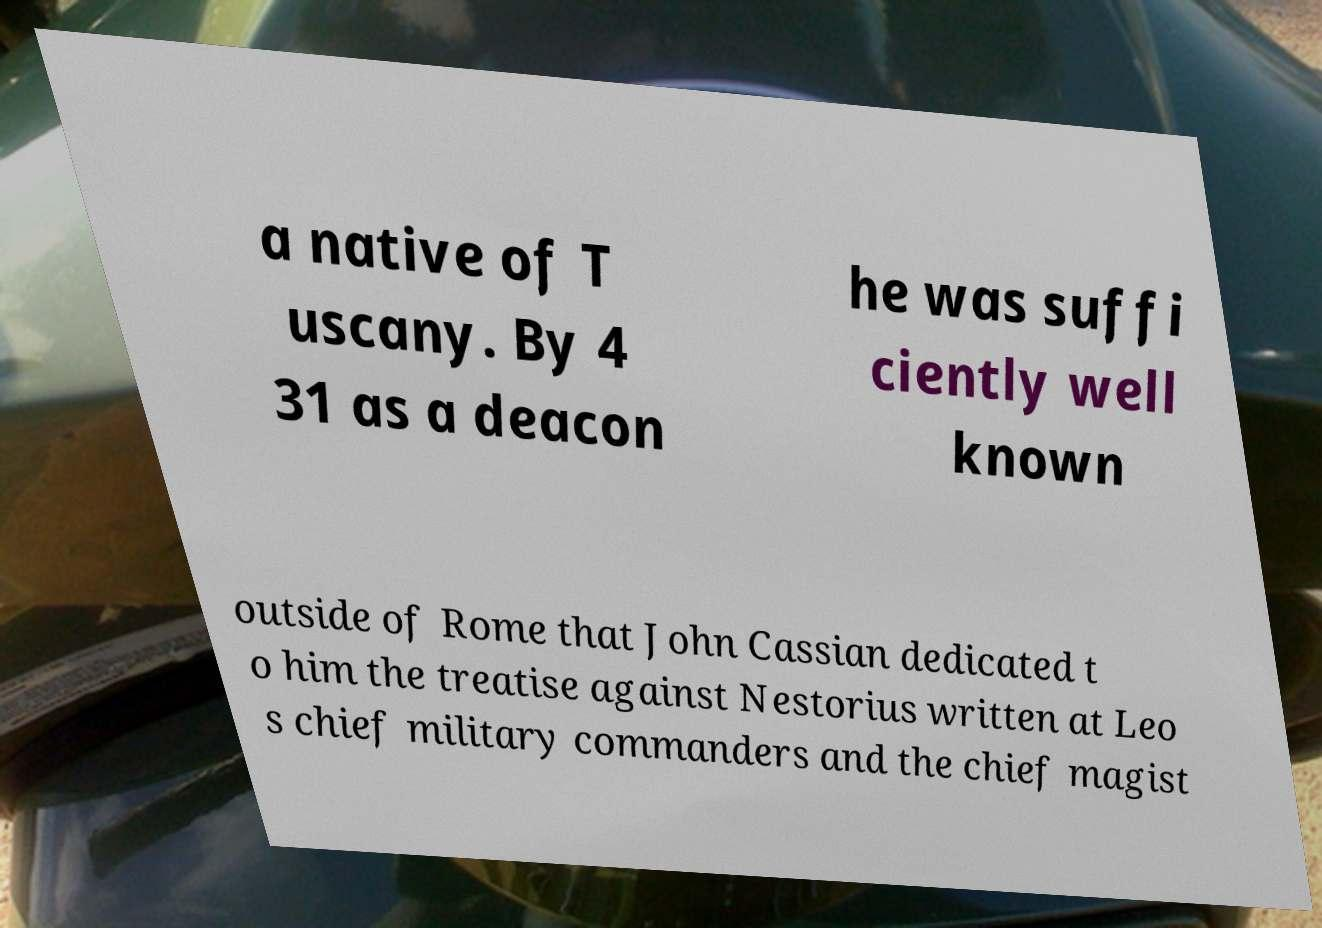What messages or text are displayed in this image? I need them in a readable, typed format. a native of T uscany. By 4 31 as a deacon he was suffi ciently well known outside of Rome that John Cassian dedicated t o him the treatise against Nestorius written at Leo s chief military commanders and the chief magist 